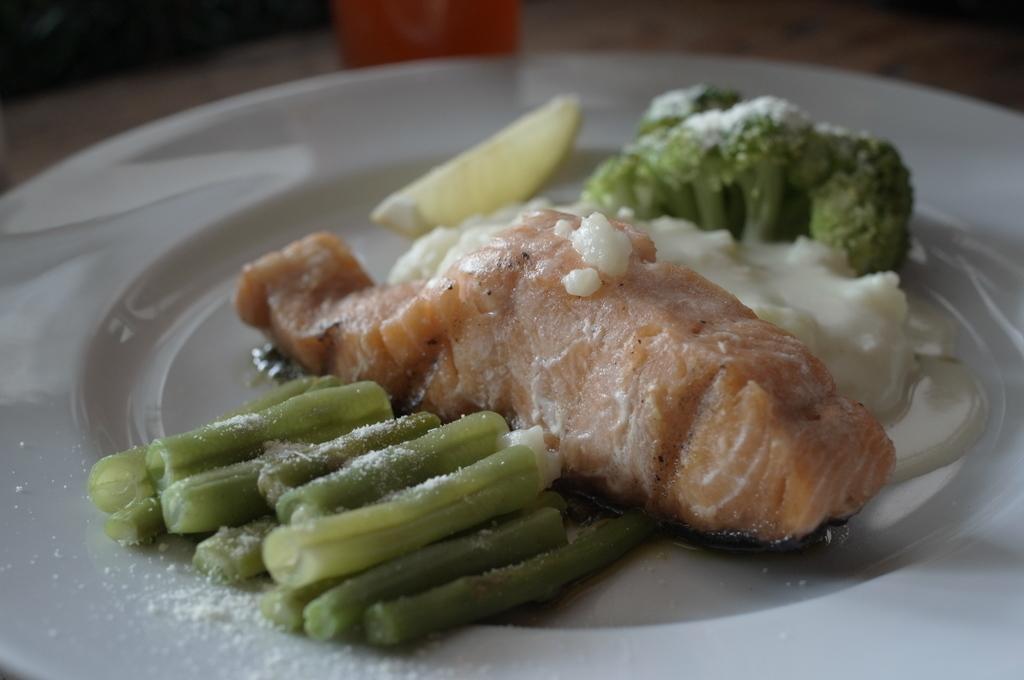Please provide a concise description of this image. In this picture I can observe some food places in the plate. The food is in green and brown color. The plate is in white color. This plate is placed on the table. 